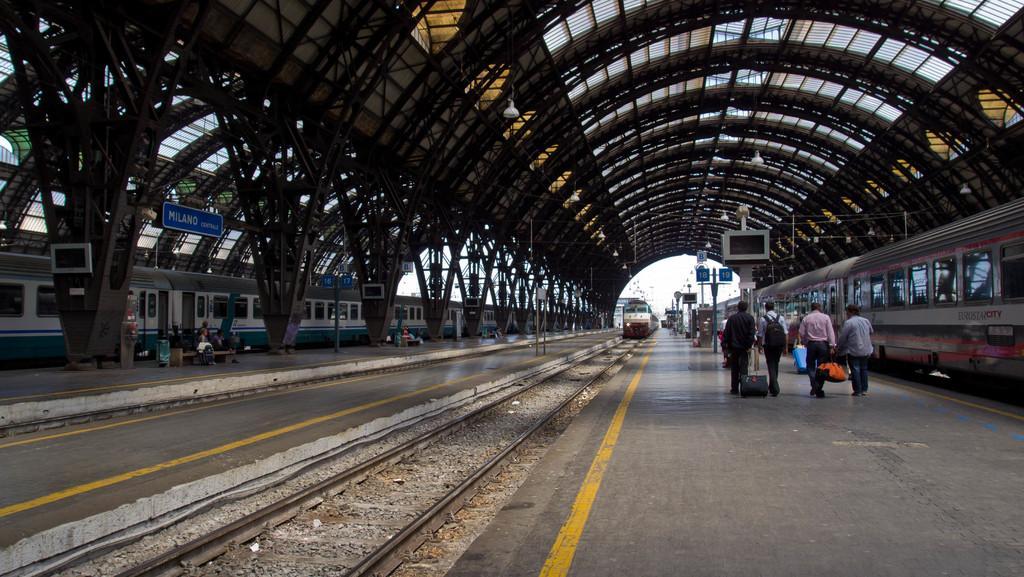Can you describe this image briefly? Trains are on track. Here we can people. One person wore bag. These are sign boards. 